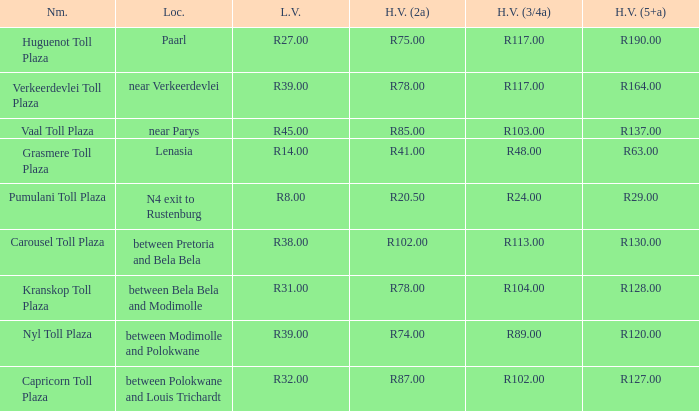What is the appellation of the piazza where the tariff for large automobiles with 2 axles sums to r8 Capricorn Toll Plaza. 